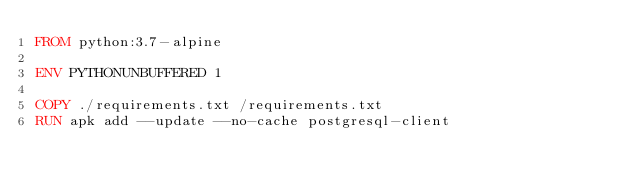Convert code to text. <code><loc_0><loc_0><loc_500><loc_500><_Dockerfile_>FROM python:3.7-alpine

ENV PYTHONUNBUFFERED 1

COPY ./requirements.txt /requirements.txt
RUN apk add --update --no-cache postgresql-client</code> 